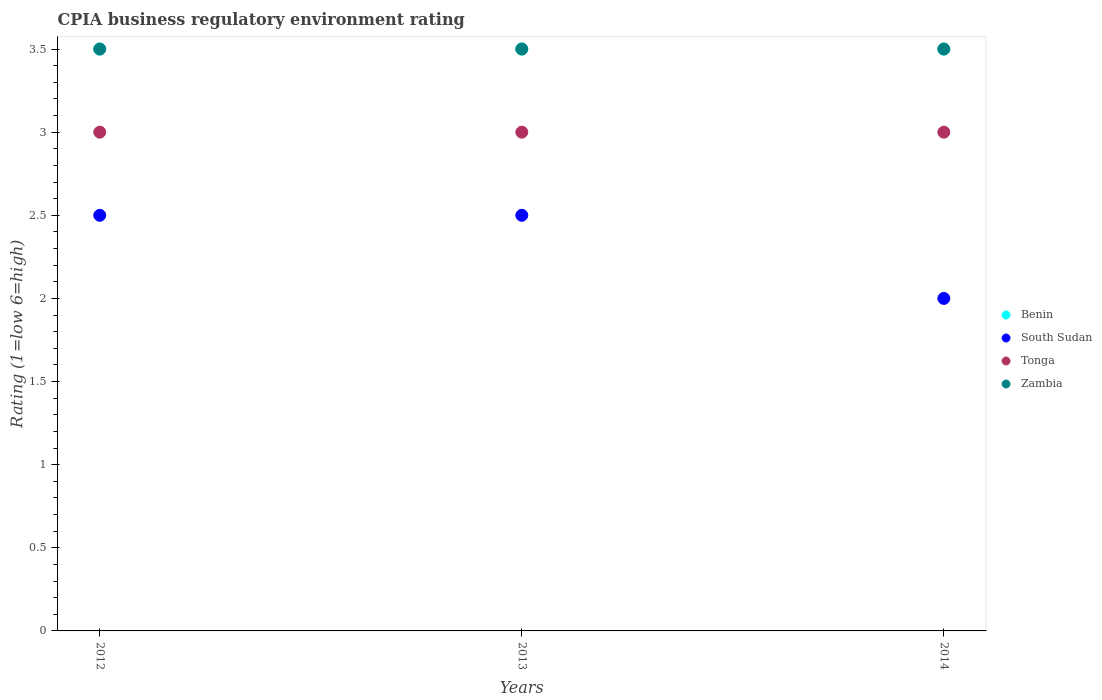How many different coloured dotlines are there?
Make the answer very short. 4. Is the number of dotlines equal to the number of legend labels?
Your response must be concise. Yes. What is the CPIA rating in Zambia in 2014?
Your answer should be compact. 3.5. Across all years, what is the maximum CPIA rating in Benin?
Offer a very short reply. 3.5. What is the total CPIA rating in Tonga in the graph?
Give a very brief answer. 9. What is the difference between the CPIA rating in Benin in 2012 and that in 2013?
Provide a short and direct response. 0. What is the average CPIA rating in Zambia per year?
Your answer should be very brief. 3.5. In the year 2012, what is the difference between the CPIA rating in Benin and CPIA rating in Tonga?
Offer a terse response. 0.5. In how many years, is the CPIA rating in South Sudan greater than 0.5?
Your answer should be compact. 3. Is the difference between the CPIA rating in Benin in 2012 and 2013 greater than the difference between the CPIA rating in Tonga in 2012 and 2013?
Your answer should be compact. No. What is the difference between the highest and the lowest CPIA rating in Tonga?
Provide a succinct answer. 0. Is the sum of the CPIA rating in South Sudan in 2012 and 2013 greater than the maximum CPIA rating in Zambia across all years?
Keep it short and to the point. Yes. Is it the case that in every year, the sum of the CPIA rating in Benin and CPIA rating in Zambia  is greater than the sum of CPIA rating in South Sudan and CPIA rating in Tonga?
Ensure brevity in your answer.  Yes. Is the CPIA rating in Zambia strictly greater than the CPIA rating in South Sudan over the years?
Your answer should be compact. Yes. Is the CPIA rating in Zambia strictly less than the CPIA rating in South Sudan over the years?
Keep it short and to the point. No. How many years are there in the graph?
Offer a terse response. 3. Does the graph contain any zero values?
Keep it short and to the point. No. Does the graph contain grids?
Keep it short and to the point. No. How many legend labels are there?
Keep it short and to the point. 4. How are the legend labels stacked?
Make the answer very short. Vertical. What is the title of the graph?
Ensure brevity in your answer.  CPIA business regulatory environment rating. Does "Algeria" appear as one of the legend labels in the graph?
Provide a succinct answer. No. What is the Rating (1=low 6=high) in Tonga in 2012?
Give a very brief answer. 3. What is the Rating (1=low 6=high) of South Sudan in 2013?
Provide a short and direct response. 2.5. What is the Rating (1=low 6=high) of Zambia in 2013?
Provide a short and direct response. 3.5. What is the Rating (1=low 6=high) of Benin in 2014?
Provide a short and direct response. 3.5. What is the Rating (1=low 6=high) in South Sudan in 2014?
Make the answer very short. 2. What is the Rating (1=low 6=high) of Tonga in 2014?
Keep it short and to the point. 3. Across all years, what is the maximum Rating (1=low 6=high) in Benin?
Provide a short and direct response. 3.5. Across all years, what is the maximum Rating (1=low 6=high) of South Sudan?
Keep it short and to the point. 2.5. Across all years, what is the maximum Rating (1=low 6=high) in Zambia?
Provide a succinct answer. 3.5. Across all years, what is the minimum Rating (1=low 6=high) in Tonga?
Offer a very short reply. 3. What is the total Rating (1=low 6=high) of South Sudan in the graph?
Ensure brevity in your answer.  7. What is the total Rating (1=low 6=high) in Zambia in the graph?
Ensure brevity in your answer.  10.5. What is the difference between the Rating (1=low 6=high) in Benin in 2012 and that in 2013?
Your response must be concise. 0. What is the difference between the Rating (1=low 6=high) in Tonga in 2012 and that in 2013?
Provide a short and direct response. 0. What is the difference between the Rating (1=low 6=high) of Tonga in 2012 and that in 2014?
Your response must be concise. 0. What is the difference between the Rating (1=low 6=high) in Benin in 2012 and the Rating (1=low 6=high) in South Sudan in 2013?
Provide a short and direct response. 1. What is the difference between the Rating (1=low 6=high) in Tonga in 2012 and the Rating (1=low 6=high) in Zambia in 2013?
Your answer should be compact. -0.5. What is the difference between the Rating (1=low 6=high) in Benin in 2012 and the Rating (1=low 6=high) in Tonga in 2014?
Ensure brevity in your answer.  0.5. What is the difference between the Rating (1=low 6=high) of Tonga in 2012 and the Rating (1=low 6=high) of Zambia in 2014?
Make the answer very short. -0.5. What is the difference between the Rating (1=low 6=high) of Benin in 2013 and the Rating (1=low 6=high) of South Sudan in 2014?
Keep it short and to the point. 1.5. What is the difference between the Rating (1=low 6=high) in Benin in 2013 and the Rating (1=low 6=high) in Zambia in 2014?
Your answer should be very brief. 0. What is the difference between the Rating (1=low 6=high) of South Sudan in 2013 and the Rating (1=low 6=high) of Tonga in 2014?
Offer a terse response. -0.5. What is the difference between the Rating (1=low 6=high) in South Sudan in 2013 and the Rating (1=low 6=high) in Zambia in 2014?
Your response must be concise. -1. What is the average Rating (1=low 6=high) of Benin per year?
Make the answer very short. 3.5. What is the average Rating (1=low 6=high) of South Sudan per year?
Keep it short and to the point. 2.33. In the year 2012, what is the difference between the Rating (1=low 6=high) in Benin and Rating (1=low 6=high) in South Sudan?
Give a very brief answer. 1. In the year 2012, what is the difference between the Rating (1=low 6=high) of Benin and Rating (1=low 6=high) of Tonga?
Keep it short and to the point. 0.5. In the year 2012, what is the difference between the Rating (1=low 6=high) in Benin and Rating (1=low 6=high) in Zambia?
Offer a very short reply. 0. In the year 2012, what is the difference between the Rating (1=low 6=high) in South Sudan and Rating (1=low 6=high) in Tonga?
Give a very brief answer. -0.5. In the year 2013, what is the difference between the Rating (1=low 6=high) of South Sudan and Rating (1=low 6=high) of Zambia?
Ensure brevity in your answer.  -1. In the year 2014, what is the difference between the Rating (1=low 6=high) in Benin and Rating (1=low 6=high) in South Sudan?
Your answer should be very brief. 1.5. In the year 2014, what is the difference between the Rating (1=low 6=high) in Benin and Rating (1=low 6=high) in Zambia?
Offer a terse response. 0. In the year 2014, what is the difference between the Rating (1=low 6=high) of Tonga and Rating (1=low 6=high) of Zambia?
Your answer should be compact. -0.5. What is the ratio of the Rating (1=low 6=high) in South Sudan in 2012 to that in 2013?
Make the answer very short. 1. What is the ratio of the Rating (1=low 6=high) in Tonga in 2012 to that in 2013?
Your answer should be compact. 1. What is the ratio of the Rating (1=low 6=high) of Zambia in 2012 to that in 2014?
Your response must be concise. 1. What is the difference between the highest and the second highest Rating (1=low 6=high) in South Sudan?
Provide a succinct answer. 0. What is the difference between the highest and the second highest Rating (1=low 6=high) of Tonga?
Your response must be concise. 0. What is the difference between the highest and the second highest Rating (1=low 6=high) in Zambia?
Ensure brevity in your answer.  0. What is the difference between the highest and the lowest Rating (1=low 6=high) of South Sudan?
Provide a short and direct response. 0.5. 